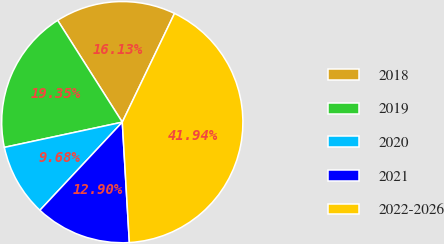<chart> <loc_0><loc_0><loc_500><loc_500><pie_chart><fcel>2018<fcel>2019<fcel>2020<fcel>2021<fcel>2022-2026<nl><fcel>16.13%<fcel>19.35%<fcel>9.68%<fcel>12.9%<fcel>41.94%<nl></chart> 